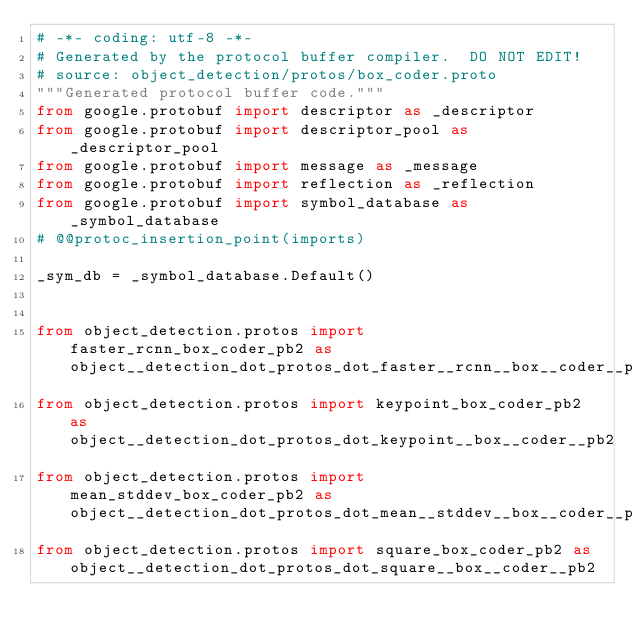Convert code to text. <code><loc_0><loc_0><loc_500><loc_500><_Python_># -*- coding: utf-8 -*-
# Generated by the protocol buffer compiler.  DO NOT EDIT!
# source: object_detection/protos/box_coder.proto
"""Generated protocol buffer code."""
from google.protobuf import descriptor as _descriptor
from google.protobuf import descriptor_pool as _descriptor_pool
from google.protobuf import message as _message
from google.protobuf import reflection as _reflection
from google.protobuf import symbol_database as _symbol_database
# @@protoc_insertion_point(imports)

_sym_db = _symbol_database.Default()


from object_detection.protos import faster_rcnn_box_coder_pb2 as object__detection_dot_protos_dot_faster__rcnn__box__coder__pb2
from object_detection.protos import keypoint_box_coder_pb2 as object__detection_dot_protos_dot_keypoint__box__coder__pb2
from object_detection.protos import mean_stddev_box_coder_pb2 as object__detection_dot_protos_dot_mean__stddev__box__coder__pb2
from object_detection.protos import square_box_coder_pb2 as object__detection_dot_protos_dot_square__box__coder__pb2

</code> 